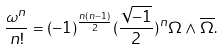Convert formula to latex. <formula><loc_0><loc_0><loc_500><loc_500>\frac { \omega ^ { n } } { n ! } = ( - 1 ) ^ { \frac { n ( n - 1 ) } { 2 } } ( \frac { \sqrt { - 1 } } { 2 } ) ^ { n } \Omega \wedge \overline { \Omega } .</formula> 